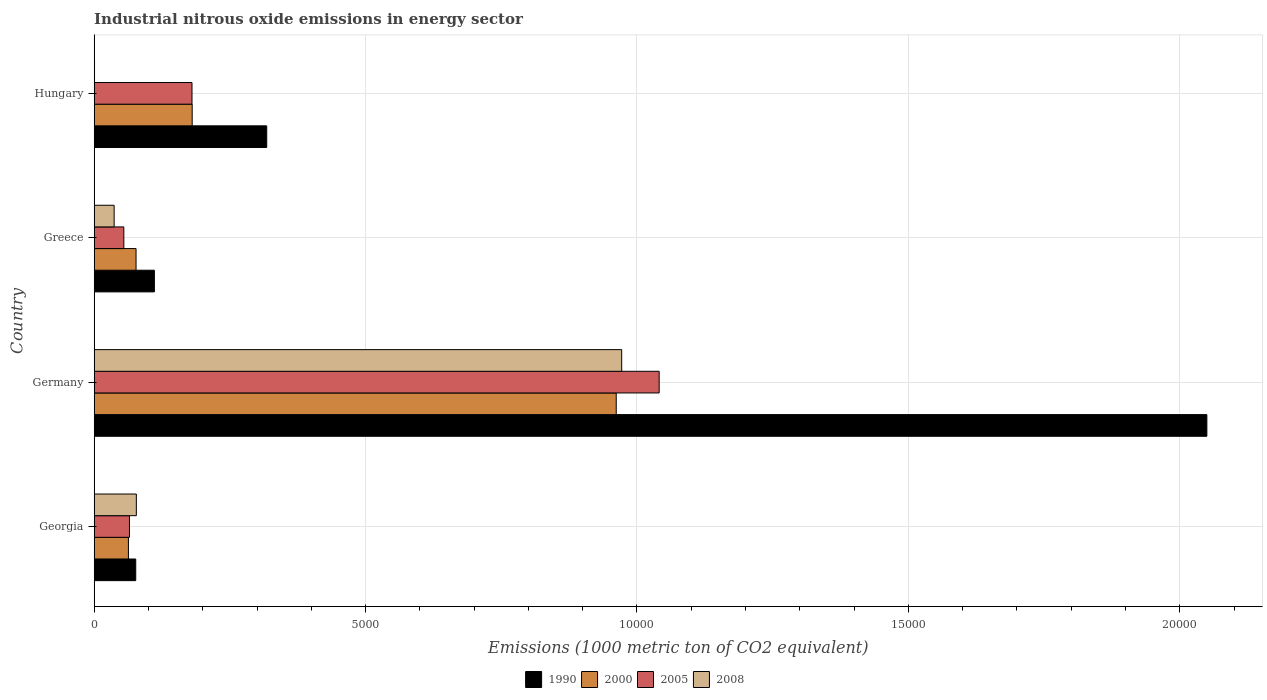How many different coloured bars are there?
Provide a succinct answer. 4. How many groups of bars are there?
Give a very brief answer. 4. Are the number of bars on each tick of the Y-axis equal?
Make the answer very short. Yes. How many bars are there on the 2nd tick from the bottom?
Your response must be concise. 4. What is the label of the 4th group of bars from the top?
Your answer should be very brief. Georgia. What is the amount of industrial nitrous oxide emitted in 2008 in Hungary?
Ensure brevity in your answer.  6. Across all countries, what is the maximum amount of industrial nitrous oxide emitted in 2005?
Your response must be concise. 1.04e+04. Across all countries, what is the minimum amount of industrial nitrous oxide emitted in 1990?
Provide a succinct answer. 765.3. In which country was the amount of industrial nitrous oxide emitted in 2000 minimum?
Offer a terse response. Georgia. What is the total amount of industrial nitrous oxide emitted in 2005 in the graph?
Ensure brevity in your answer.  1.34e+04. What is the difference between the amount of industrial nitrous oxide emitted in 2008 in Germany and that in Hungary?
Provide a succinct answer. 9712.4. What is the difference between the amount of industrial nitrous oxide emitted in 2000 in Greece and the amount of industrial nitrous oxide emitted in 2005 in Hungary?
Provide a succinct answer. -1031. What is the average amount of industrial nitrous oxide emitted in 2005 per country?
Ensure brevity in your answer.  3351.7. What is the difference between the amount of industrial nitrous oxide emitted in 2000 and amount of industrial nitrous oxide emitted in 2005 in Georgia?
Give a very brief answer. -19.6. In how many countries, is the amount of industrial nitrous oxide emitted in 1990 greater than 17000 1000 metric ton?
Provide a succinct answer. 1. What is the ratio of the amount of industrial nitrous oxide emitted in 1990 in Germany to that in Greece?
Provide a succinct answer. 18.48. What is the difference between the highest and the second highest amount of industrial nitrous oxide emitted in 2005?
Ensure brevity in your answer.  8606.9. What is the difference between the highest and the lowest amount of industrial nitrous oxide emitted in 2005?
Provide a succinct answer. 9863.1. In how many countries, is the amount of industrial nitrous oxide emitted in 2000 greater than the average amount of industrial nitrous oxide emitted in 2000 taken over all countries?
Keep it short and to the point. 1. What does the 3rd bar from the top in Germany represents?
Offer a very short reply. 2000. What does the 1st bar from the bottom in Georgia represents?
Keep it short and to the point. 1990. What is the difference between two consecutive major ticks on the X-axis?
Your response must be concise. 5000. Where does the legend appear in the graph?
Provide a succinct answer. Bottom center. How many legend labels are there?
Ensure brevity in your answer.  4. How are the legend labels stacked?
Provide a short and direct response. Horizontal. What is the title of the graph?
Your answer should be compact. Industrial nitrous oxide emissions in energy sector. What is the label or title of the X-axis?
Offer a terse response. Emissions (1000 metric ton of CO2 equivalent). What is the Emissions (1000 metric ton of CO2 equivalent) in 1990 in Georgia?
Ensure brevity in your answer.  765.3. What is the Emissions (1000 metric ton of CO2 equivalent) of 2000 in Georgia?
Provide a succinct answer. 630.5. What is the Emissions (1000 metric ton of CO2 equivalent) of 2005 in Georgia?
Your response must be concise. 650.1. What is the Emissions (1000 metric ton of CO2 equivalent) in 2008 in Georgia?
Your response must be concise. 776.5. What is the Emissions (1000 metric ton of CO2 equivalent) of 1990 in Germany?
Your answer should be compact. 2.05e+04. What is the Emissions (1000 metric ton of CO2 equivalent) of 2000 in Germany?
Make the answer very short. 9617.9. What is the Emissions (1000 metric ton of CO2 equivalent) of 2005 in Germany?
Ensure brevity in your answer.  1.04e+04. What is the Emissions (1000 metric ton of CO2 equivalent) of 2008 in Germany?
Offer a terse response. 9718.4. What is the Emissions (1000 metric ton of CO2 equivalent) of 1990 in Greece?
Make the answer very short. 1109.1. What is the Emissions (1000 metric ton of CO2 equivalent) in 2000 in Greece?
Your response must be concise. 771. What is the Emissions (1000 metric ton of CO2 equivalent) of 2005 in Greece?
Your answer should be compact. 545.8. What is the Emissions (1000 metric ton of CO2 equivalent) in 2008 in Greece?
Your answer should be compact. 367.4. What is the Emissions (1000 metric ton of CO2 equivalent) in 1990 in Hungary?
Give a very brief answer. 3178.6. What is the Emissions (1000 metric ton of CO2 equivalent) in 2000 in Hungary?
Your answer should be compact. 1805.4. What is the Emissions (1000 metric ton of CO2 equivalent) in 2005 in Hungary?
Your answer should be very brief. 1802. What is the Emissions (1000 metric ton of CO2 equivalent) in 2008 in Hungary?
Offer a terse response. 6. Across all countries, what is the maximum Emissions (1000 metric ton of CO2 equivalent) of 1990?
Offer a very short reply. 2.05e+04. Across all countries, what is the maximum Emissions (1000 metric ton of CO2 equivalent) in 2000?
Give a very brief answer. 9617.9. Across all countries, what is the maximum Emissions (1000 metric ton of CO2 equivalent) in 2005?
Ensure brevity in your answer.  1.04e+04. Across all countries, what is the maximum Emissions (1000 metric ton of CO2 equivalent) of 2008?
Ensure brevity in your answer.  9718.4. Across all countries, what is the minimum Emissions (1000 metric ton of CO2 equivalent) in 1990?
Offer a terse response. 765.3. Across all countries, what is the minimum Emissions (1000 metric ton of CO2 equivalent) in 2000?
Ensure brevity in your answer.  630.5. Across all countries, what is the minimum Emissions (1000 metric ton of CO2 equivalent) in 2005?
Provide a short and direct response. 545.8. Across all countries, what is the minimum Emissions (1000 metric ton of CO2 equivalent) of 2008?
Your answer should be compact. 6. What is the total Emissions (1000 metric ton of CO2 equivalent) of 1990 in the graph?
Your answer should be compact. 2.56e+04. What is the total Emissions (1000 metric ton of CO2 equivalent) of 2000 in the graph?
Keep it short and to the point. 1.28e+04. What is the total Emissions (1000 metric ton of CO2 equivalent) of 2005 in the graph?
Your response must be concise. 1.34e+04. What is the total Emissions (1000 metric ton of CO2 equivalent) in 2008 in the graph?
Your answer should be very brief. 1.09e+04. What is the difference between the Emissions (1000 metric ton of CO2 equivalent) in 1990 in Georgia and that in Germany?
Make the answer very short. -1.97e+04. What is the difference between the Emissions (1000 metric ton of CO2 equivalent) in 2000 in Georgia and that in Germany?
Offer a very short reply. -8987.4. What is the difference between the Emissions (1000 metric ton of CO2 equivalent) of 2005 in Georgia and that in Germany?
Your answer should be compact. -9758.8. What is the difference between the Emissions (1000 metric ton of CO2 equivalent) of 2008 in Georgia and that in Germany?
Make the answer very short. -8941.9. What is the difference between the Emissions (1000 metric ton of CO2 equivalent) in 1990 in Georgia and that in Greece?
Ensure brevity in your answer.  -343.8. What is the difference between the Emissions (1000 metric ton of CO2 equivalent) in 2000 in Georgia and that in Greece?
Keep it short and to the point. -140.5. What is the difference between the Emissions (1000 metric ton of CO2 equivalent) in 2005 in Georgia and that in Greece?
Provide a short and direct response. 104.3. What is the difference between the Emissions (1000 metric ton of CO2 equivalent) of 2008 in Georgia and that in Greece?
Your answer should be very brief. 409.1. What is the difference between the Emissions (1000 metric ton of CO2 equivalent) in 1990 in Georgia and that in Hungary?
Make the answer very short. -2413.3. What is the difference between the Emissions (1000 metric ton of CO2 equivalent) of 2000 in Georgia and that in Hungary?
Provide a succinct answer. -1174.9. What is the difference between the Emissions (1000 metric ton of CO2 equivalent) of 2005 in Georgia and that in Hungary?
Give a very brief answer. -1151.9. What is the difference between the Emissions (1000 metric ton of CO2 equivalent) in 2008 in Georgia and that in Hungary?
Provide a succinct answer. 770.5. What is the difference between the Emissions (1000 metric ton of CO2 equivalent) of 1990 in Germany and that in Greece?
Provide a succinct answer. 1.94e+04. What is the difference between the Emissions (1000 metric ton of CO2 equivalent) in 2000 in Germany and that in Greece?
Ensure brevity in your answer.  8846.9. What is the difference between the Emissions (1000 metric ton of CO2 equivalent) in 2005 in Germany and that in Greece?
Give a very brief answer. 9863.1. What is the difference between the Emissions (1000 metric ton of CO2 equivalent) in 2008 in Germany and that in Greece?
Provide a succinct answer. 9351. What is the difference between the Emissions (1000 metric ton of CO2 equivalent) of 1990 in Germany and that in Hungary?
Provide a succinct answer. 1.73e+04. What is the difference between the Emissions (1000 metric ton of CO2 equivalent) of 2000 in Germany and that in Hungary?
Offer a very short reply. 7812.5. What is the difference between the Emissions (1000 metric ton of CO2 equivalent) in 2005 in Germany and that in Hungary?
Your answer should be compact. 8606.9. What is the difference between the Emissions (1000 metric ton of CO2 equivalent) of 2008 in Germany and that in Hungary?
Your answer should be very brief. 9712.4. What is the difference between the Emissions (1000 metric ton of CO2 equivalent) in 1990 in Greece and that in Hungary?
Your answer should be very brief. -2069.5. What is the difference between the Emissions (1000 metric ton of CO2 equivalent) in 2000 in Greece and that in Hungary?
Give a very brief answer. -1034.4. What is the difference between the Emissions (1000 metric ton of CO2 equivalent) of 2005 in Greece and that in Hungary?
Offer a terse response. -1256.2. What is the difference between the Emissions (1000 metric ton of CO2 equivalent) of 2008 in Greece and that in Hungary?
Offer a terse response. 361.4. What is the difference between the Emissions (1000 metric ton of CO2 equivalent) of 1990 in Georgia and the Emissions (1000 metric ton of CO2 equivalent) of 2000 in Germany?
Keep it short and to the point. -8852.6. What is the difference between the Emissions (1000 metric ton of CO2 equivalent) in 1990 in Georgia and the Emissions (1000 metric ton of CO2 equivalent) in 2005 in Germany?
Your answer should be very brief. -9643.6. What is the difference between the Emissions (1000 metric ton of CO2 equivalent) in 1990 in Georgia and the Emissions (1000 metric ton of CO2 equivalent) in 2008 in Germany?
Your response must be concise. -8953.1. What is the difference between the Emissions (1000 metric ton of CO2 equivalent) of 2000 in Georgia and the Emissions (1000 metric ton of CO2 equivalent) of 2005 in Germany?
Keep it short and to the point. -9778.4. What is the difference between the Emissions (1000 metric ton of CO2 equivalent) of 2000 in Georgia and the Emissions (1000 metric ton of CO2 equivalent) of 2008 in Germany?
Your answer should be compact. -9087.9. What is the difference between the Emissions (1000 metric ton of CO2 equivalent) of 2005 in Georgia and the Emissions (1000 metric ton of CO2 equivalent) of 2008 in Germany?
Offer a terse response. -9068.3. What is the difference between the Emissions (1000 metric ton of CO2 equivalent) in 1990 in Georgia and the Emissions (1000 metric ton of CO2 equivalent) in 2000 in Greece?
Offer a terse response. -5.7. What is the difference between the Emissions (1000 metric ton of CO2 equivalent) in 1990 in Georgia and the Emissions (1000 metric ton of CO2 equivalent) in 2005 in Greece?
Provide a short and direct response. 219.5. What is the difference between the Emissions (1000 metric ton of CO2 equivalent) of 1990 in Georgia and the Emissions (1000 metric ton of CO2 equivalent) of 2008 in Greece?
Make the answer very short. 397.9. What is the difference between the Emissions (1000 metric ton of CO2 equivalent) of 2000 in Georgia and the Emissions (1000 metric ton of CO2 equivalent) of 2005 in Greece?
Make the answer very short. 84.7. What is the difference between the Emissions (1000 metric ton of CO2 equivalent) in 2000 in Georgia and the Emissions (1000 metric ton of CO2 equivalent) in 2008 in Greece?
Offer a terse response. 263.1. What is the difference between the Emissions (1000 metric ton of CO2 equivalent) in 2005 in Georgia and the Emissions (1000 metric ton of CO2 equivalent) in 2008 in Greece?
Provide a short and direct response. 282.7. What is the difference between the Emissions (1000 metric ton of CO2 equivalent) in 1990 in Georgia and the Emissions (1000 metric ton of CO2 equivalent) in 2000 in Hungary?
Make the answer very short. -1040.1. What is the difference between the Emissions (1000 metric ton of CO2 equivalent) in 1990 in Georgia and the Emissions (1000 metric ton of CO2 equivalent) in 2005 in Hungary?
Give a very brief answer. -1036.7. What is the difference between the Emissions (1000 metric ton of CO2 equivalent) of 1990 in Georgia and the Emissions (1000 metric ton of CO2 equivalent) of 2008 in Hungary?
Keep it short and to the point. 759.3. What is the difference between the Emissions (1000 metric ton of CO2 equivalent) of 2000 in Georgia and the Emissions (1000 metric ton of CO2 equivalent) of 2005 in Hungary?
Your answer should be very brief. -1171.5. What is the difference between the Emissions (1000 metric ton of CO2 equivalent) of 2000 in Georgia and the Emissions (1000 metric ton of CO2 equivalent) of 2008 in Hungary?
Your answer should be compact. 624.5. What is the difference between the Emissions (1000 metric ton of CO2 equivalent) of 2005 in Georgia and the Emissions (1000 metric ton of CO2 equivalent) of 2008 in Hungary?
Ensure brevity in your answer.  644.1. What is the difference between the Emissions (1000 metric ton of CO2 equivalent) of 1990 in Germany and the Emissions (1000 metric ton of CO2 equivalent) of 2000 in Greece?
Keep it short and to the point. 1.97e+04. What is the difference between the Emissions (1000 metric ton of CO2 equivalent) of 1990 in Germany and the Emissions (1000 metric ton of CO2 equivalent) of 2005 in Greece?
Your answer should be compact. 2.00e+04. What is the difference between the Emissions (1000 metric ton of CO2 equivalent) in 1990 in Germany and the Emissions (1000 metric ton of CO2 equivalent) in 2008 in Greece?
Your response must be concise. 2.01e+04. What is the difference between the Emissions (1000 metric ton of CO2 equivalent) in 2000 in Germany and the Emissions (1000 metric ton of CO2 equivalent) in 2005 in Greece?
Make the answer very short. 9072.1. What is the difference between the Emissions (1000 metric ton of CO2 equivalent) of 2000 in Germany and the Emissions (1000 metric ton of CO2 equivalent) of 2008 in Greece?
Offer a terse response. 9250.5. What is the difference between the Emissions (1000 metric ton of CO2 equivalent) in 2005 in Germany and the Emissions (1000 metric ton of CO2 equivalent) in 2008 in Greece?
Give a very brief answer. 1.00e+04. What is the difference between the Emissions (1000 metric ton of CO2 equivalent) in 1990 in Germany and the Emissions (1000 metric ton of CO2 equivalent) in 2000 in Hungary?
Offer a very short reply. 1.87e+04. What is the difference between the Emissions (1000 metric ton of CO2 equivalent) of 1990 in Germany and the Emissions (1000 metric ton of CO2 equivalent) of 2005 in Hungary?
Your response must be concise. 1.87e+04. What is the difference between the Emissions (1000 metric ton of CO2 equivalent) of 1990 in Germany and the Emissions (1000 metric ton of CO2 equivalent) of 2008 in Hungary?
Provide a short and direct response. 2.05e+04. What is the difference between the Emissions (1000 metric ton of CO2 equivalent) in 2000 in Germany and the Emissions (1000 metric ton of CO2 equivalent) in 2005 in Hungary?
Give a very brief answer. 7815.9. What is the difference between the Emissions (1000 metric ton of CO2 equivalent) in 2000 in Germany and the Emissions (1000 metric ton of CO2 equivalent) in 2008 in Hungary?
Offer a very short reply. 9611.9. What is the difference between the Emissions (1000 metric ton of CO2 equivalent) in 2005 in Germany and the Emissions (1000 metric ton of CO2 equivalent) in 2008 in Hungary?
Make the answer very short. 1.04e+04. What is the difference between the Emissions (1000 metric ton of CO2 equivalent) of 1990 in Greece and the Emissions (1000 metric ton of CO2 equivalent) of 2000 in Hungary?
Give a very brief answer. -696.3. What is the difference between the Emissions (1000 metric ton of CO2 equivalent) of 1990 in Greece and the Emissions (1000 metric ton of CO2 equivalent) of 2005 in Hungary?
Offer a terse response. -692.9. What is the difference between the Emissions (1000 metric ton of CO2 equivalent) of 1990 in Greece and the Emissions (1000 metric ton of CO2 equivalent) of 2008 in Hungary?
Make the answer very short. 1103.1. What is the difference between the Emissions (1000 metric ton of CO2 equivalent) of 2000 in Greece and the Emissions (1000 metric ton of CO2 equivalent) of 2005 in Hungary?
Your answer should be very brief. -1031. What is the difference between the Emissions (1000 metric ton of CO2 equivalent) of 2000 in Greece and the Emissions (1000 metric ton of CO2 equivalent) of 2008 in Hungary?
Offer a terse response. 765. What is the difference between the Emissions (1000 metric ton of CO2 equivalent) of 2005 in Greece and the Emissions (1000 metric ton of CO2 equivalent) of 2008 in Hungary?
Offer a terse response. 539.8. What is the average Emissions (1000 metric ton of CO2 equivalent) of 1990 per country?
Your answer should be compact. 6388.15. What is the average Emissions (1000 metric ton of CO2 equivalent) of 2000 per country?
Offer a very short reply. 3206.2. What is the average Emissions (1000 metric ton of CO2 equivalent) of 2005 per country?
Make the answer very short. 3351.7. What is the average Emissions (1000 metric ton of CO2 equivalent) of 2008 per country?
Keep it short and to the point. 2717.07. What is the difference between the Emissions (1000 metric ton of CO2 equivalent) in 1990 and Emissions (1000 metric ton of CO2 equivalent) in 2000 in Georgia?
Make the answer very short. 134.8. What is the difference between the Emissions (1000 metric ton of CO2 equivalent) in 1990 and Emissions (1000 metric ton of CO2 equivalent) in 2005 in Georgia?
Make the answer very short. 115.2. What is the difference between the Emissions (1000 metric ton of CO2 equivalent) of 1990 and Emissions (1000 metric ton of CO2 equivalent) of 2008 in Georgia?
Offer a very short reply. -11.2. What is the difference between the Emissions (1000 metric ton of CO2 equivalent) of 2000 and Emissions (1000 metric ton of CO2 equivalent) of 2005 in Georgia?
Make the answer very short. -19.6. What is the difference between the Emissions (1000 metric ton of CO2 equivalent) in 2000 and Emissions (1000 metric ton of CO2 equivalent) in 2008 in Georgia?
Offer a very short reply. -146. What is the difference between the Emissions (1000 metric ton of CO2 equivalent) in 2005 and Emissions (1000 metric ton of CO2 equivalent) in 2008 in Georgia?
Ensure brevity in your answer.  -126.4. What is the difference between the Emissions (1000 metric ton of CO2 equivalent) in 1990 and Emissions (1000 metric ton of CO2 equivalent) in 2000 in Germany?
Ensure brevity in your answer.  1.09e+04. What is the difference between the Emissions (1000 metric ton of CO2 equivalent) of 1990 and Emissions (1000 metric ton of CO2 equivalent) of 2005 in Germany?
Your answer should be compact. 1.01e+04. What is the difference between the Emissions (1000 metric ton of CO2 equivalent) of 1990 and Emissions (1000 metric ton of CO2 equivalent) of 2008 in Germany?
Your answer should be very brief. 1.08e+04. What is the difference between the Emissions (1000 metric ton of CO2 equivalent) of 2000 and Emissions (1000 metric ton of CO2 equivalent) of 2005 in Germany?
Offer a very short reply. -791. What is the difference between the Emissions (1000 metric ton of CO2 equivalent) in 2000 and Emissions (1000 metric ton of CO2 equivalent) in 2008 in Germany?
Make the answer very short. -100.5. What is the difference between the Emissions (1000 metric ton of CO2 equivalent) of 2005 and Emissions (1000 metric ton of CO2 equivalent) of 2008 in Germany?
Your answer should be very brief. 690.5. What is the difference between the Emissions (1000 metric ton of CO2 equivalent) of 1990 and Emissions (1000 metric ton of CO2 equivalent) of 2000 in Greece?
Give a very brief answer. 338.1. What is the difference between the Emissions (1000 metric ton of CO2 equivalent) of 1990 and Emissions (1000 metric ton of CO2 equivalent) of 2005 in Greece?
Your response must be concise. 563.3. What is the difference between the Emissions (1000 metric ton of CO2 equivalent) in 1990 and Emissions (1000 metric ton of CO2 equivalent) in 2008 in Greece?
Keep it short and to the point. 741.7. What is the difference between the Emissions (1000 metric ton of CO2 equivalent) of 2000 and Emissions (1000 metric ton of CO2 equivalent) of 2005 in Greece?
Your response must be concise. 225.2. What is the difference between the Emissions (1000 metric ton of CO2 equivalent) of 2000 and Emissions (1000 metric ton of CO2 equivalent) of 2008 in Greece?
Your answer should be very brief. 403.6. What is the difference between the Emissions (1000 metric ton of CO2 equivalent) of 2005 and Emissions (1000 metric ton of CO2 equivalent) of 2008 in Greece?
Offer a terse response. 178.4. What is the difference between the Emissions (1000 metric ton of CO2 equivalent) in 1990 and Emissions (1000 metric ton of CO2 equivalent) in 2000 in Hungary?
Your answer should be very brief. 1373.2. What is the difference between the Emissions (1000 metric ton of CO2 equivalent) of 1990 and Emissions (1000 metric ton of CO2 equivalent) of 2005 in Hungary?
Your response must be concise. 1376.6. What is the difference between the Emissions (1000 metric ton of CO2 equivalent) in 1990 and Emissions (1000 metric ton of CO2 equivalent) in 2008 in Hungary?
Offer a terse response. 3172.6. What is the difference between the Emissions (1000 metric ton of CO2 equivalent) of 2000 and Emissions (1000 metric ton of CO2 equivalent) of 2005 in Hungary?
Ensure brevity in your answer.  3.4. What is the difference between the Emissions (1000 metric ton of CO2 equivalent) of 2000 and Emissions (1000 metric ton of CO2 equivalent) of 2008 in Hungary?
Offer a very short reply. 1799.4. What is the difference between the Emissions (1000 metric ton of CO2 equivalent) of 2005 and Emissions (1000 metric ton of CO2 equivalent) of 2008 in Hungary?
Your response must be concise. 1796. What is the ratio of the Emissions (1000 metric ton of CO2 equivalent) in 1990 in Georgia to that in Germany?
Give a very brief answer. 0.04. What is the ratio of the Emissions (1000 metric ton of CO2 equivalent) in 2000 in Georgia to that in Germany?
Ensure brevity in your answer.  0.07. What is the ratio of the Emissions (1000 metric ton of CO2 equivalent) in 2005 in Georgia to that in Germany?
Offer a very short reply. 0.06. What is the ratio of the Emissions (1000 metric ton of CO2 equivalent) in 2008 in Georgia to that in Germany?
Make the answer very short. 0.08. What is the ratio of the Emissions (1000 metric ton of CO2 equivalent) of 1990 in Georgia to that in Greece?
Your answer should be compact. 0.69. What is the ratio of the Emissions (1000 metric ton of CO2 equivalent) of 2000 in Georgia to that in Greece?
Provide a succinct answer. 0.82. What is the ratio of the Emissions (1000 metric ton of CO2 equivalent) in 2005 in Georgia to that in Greece?
Keep it short and to the point. 1.19. What is the ratio of the Emissions (1000 metric ton of CO2 equivalent) of 2008 in Georgia to that in Greece?
Your response must be concise. 2.11. What is the ratio of the Emissions (1000 metric ton of CO2 equivalent) of 1990 in Georgia to that in Hungary?
Your response must be concise. 0.24. What is the ratio of the Emissions (1000 metric ton of CO2 equivalent) of 2000 in Georgia to that in Hungary?
Make the answer very short. 0.35. What is the ratio of the Emissions (1000 metric ton of CO2 equivalent) of 2005 in Georgia to that in Hungary?
Give a very brief answer. 0.36. What is the ratio of the Emissions (1000 metric ton of CO2 equivalent) of 2008 in Georgia to that in Hungary?
Provide a succinct answer. 129.42. What is the ratio of the Emissions (1000 metric ton of CO2 equivalent) of 1990 in Germany to that in Greece?
Offer a terse response. 18.48. What is the ratio of the Emissions (1000 metric ton of CO2 equivalent) in 2000 in Germany to that in Greece?
Give a very brief answer. 12.47. What is the ratio of the Emissions (1000 metric ton of CO2 equivalent) of 2005 in Germany to that in Greece?
Your response must be concise. 19.07. What is the ratio of the Emissions (1000 metric ton of CO2 equivalent) of 2008 in Germany to that in Greece?
Make the answer very short. 26.45. What is the ratio of the Emissions (1000 metric ton of CO2 equivalent) of 1990 in Germany to that in Hungary?
Offer a very short reply. 6.45. What is the ratio of the Emissions (1000 metric ton of CO2 equivalent) of 2000 in Germany to that in Hungary?
Offer a terse response. 5.33. What is the ratio of the Emissions (1000 metric ton of CO2 equivalent) in 2005 in Germany to that in Hungary?
Keep it short and to the point. 5.78. What is the ratio of the Emissions (1000 metric ton of CO2 equivalent) of 2008 in Germany to that in Hungary?
Your response must be concise. 1619.73. What is the ratio of the Emissions (1000 metric ton of CO2 equivalent) in 1990 in Greece to that in Hungary?
Give a very brief answer. 0.35. What is the ratio of the Emissions (1000 metric ton of CO2 equivalent) of 2000 in Greece to that in Hungary?
Provide a short and direct response. 0.43. What is the ratio of the Emissions (1000 metric ton of CO2 equivalent) in 2005 in Greece to that in Hungary?
Your answer should be compact. 0.3. What is the ratio of the Emissions (1000 metric ton of CO2 equivalent) in 2008 in Greece to that in Hungary?
Give a very brief answer. 61.23. What is the difference between the highest and the second highest Emissions (1000 metric ton of CO2 equivalent) of 1990?
Offer a very short reply. 1.73e+04. What is the difference between the highest and the second highest Emissions (1000 metric ton of CO2 equivalent) of 2000?
Your response must be concise. 7812.5. What is the difference between the highest and the second highest Emissions (1000 metric ton of CO2 equivalent) in 2005?
Ensure brevity in your answer.  8606.9. What is the difference between the highest and the second highest Emissions (1000 metric ton of CO2 equivalent) in 2008?
Make the answer very short. 8941.9. What is the difference between the highest and the lowest Emissions (1000 metric ton of CO2 equivalent) of 1990?
Keep it short and to the point. 1.97e+04. What is the difference between the highest and the lowest Emissions (1000 metric ton of CO2 equivalent) in 2000?
Your answer should be very brief. 8987.4. What is the difference between the highest and the lowest Emissions (1000 metric ton of CO2 equivalent) of 2005?
Ensure brevity in your answer.  9863.1. What is the difference between the highest and the lowest Emissions (1000 metric ton of CO2 equivalent) in 2008?
Provide a succinct answer. 9712.4. 